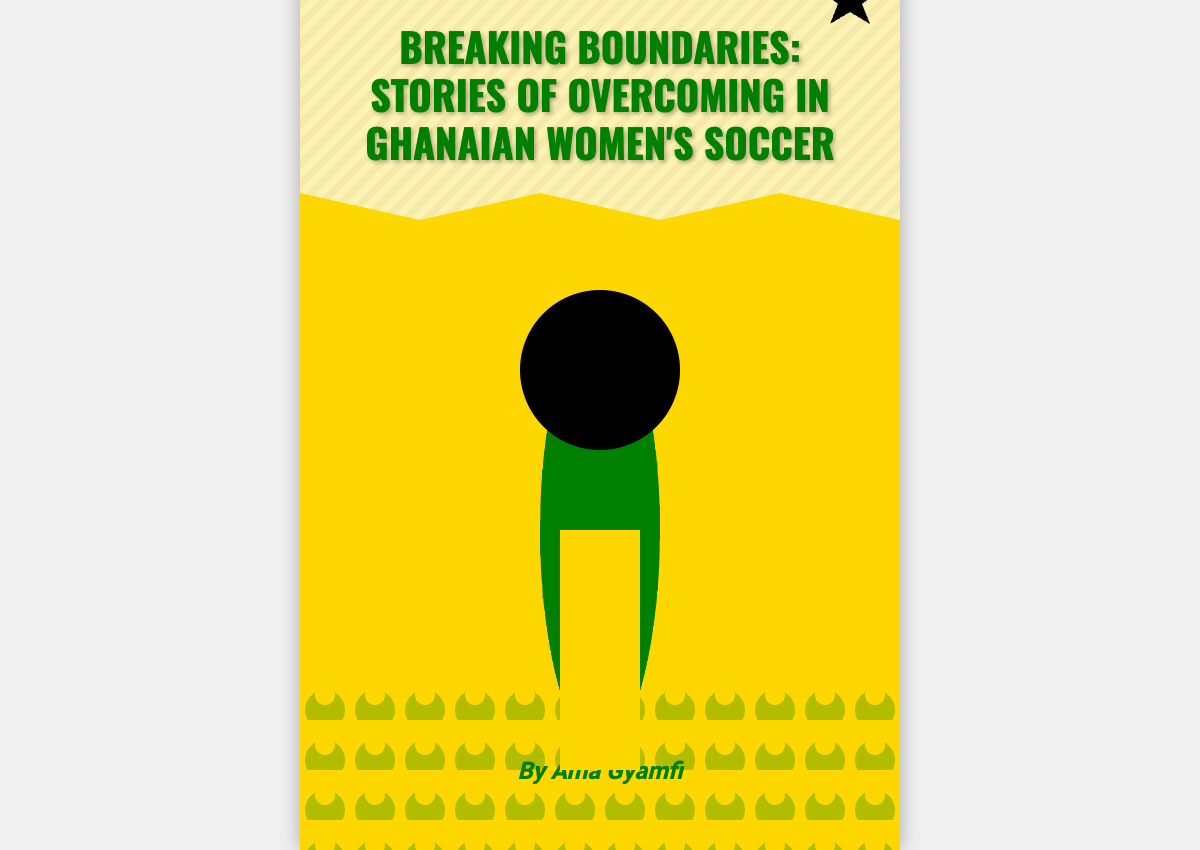What is the title of the book? The title of the book is prominently displayed at the top of the cover.
Answer: Breaking Boundaries: Stories of Overcoming in Ghanaian Women's Soccer Who is the author of the book? The author’s name is listed at the bottom of the cover.
Answer: Ama Gyamfi What color is the book cover? The background color of the book cover is specified in the document styling.
Answer: Gold What does the glass ceiling symbolize? The glass ceiling in the design symbolizes barriers that women face in society.
Answer: Barriers What is illustrated as the main image of the cover? The main image is a depiction of a female footballer on the cover.
Answer: Female footballer How many main sections are visible in the design? The design consists of multiple sections including the title, author, player, glass ceiling, and crowd.
Answer: Five What does the emblem on the cover represent? The emblem is a significant symbol incorporated into the design, often representing strength and unity in sports.
Answer: Strength What visual element represents the audience? The crowd section visually represents the audience on the cover.
Answer: Crowd In what position is the title located on the cover? The title is positioned near the top of the book cover.
Answer: Top 